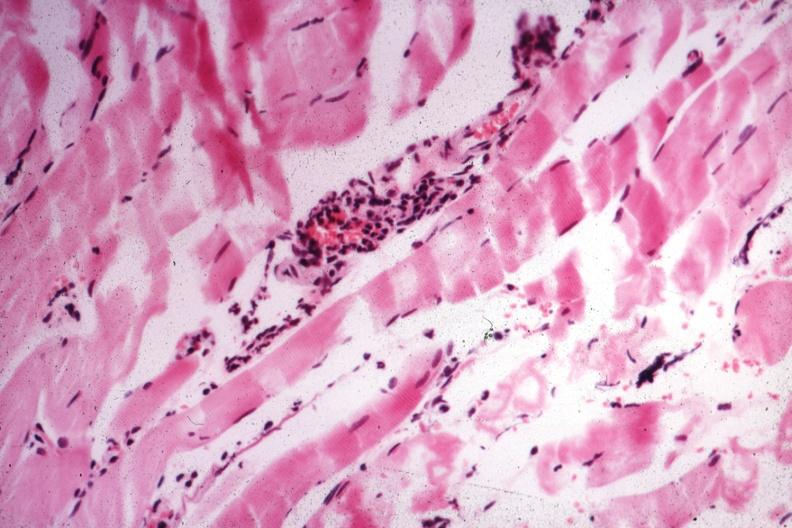does this image show small lymphorrhages?
Answer the question using a single word or phrase. Yes 